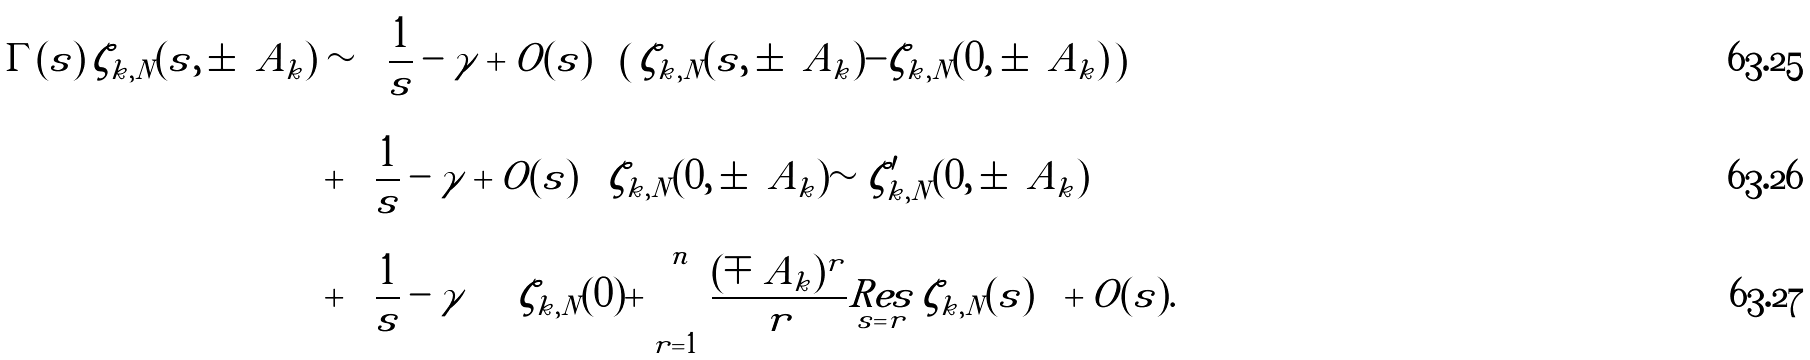Convert formula to latex. <formula><loc_0><loc_0><loc_500><loc_500>\Gamma ( s ) \, \zeta _ { k , N } ( s , \pm \ A _ { k } ) & \sim \left ( \frac { 1 } { s } - \gamma + O ( s ) \right ) \left ( \, \zeta _ { k , N } ( s , \pm \ A _ { k } ) - \zeta _ { k , N } ( 0 , \pm \ A _ { k } ) \, \right ) \\ & + \left ( \frac { 1 } { s } - \gamma + O ( s ) \right ) \zeta _ { k , N } ( 0 , \pm \ A _ { k } ) \sim \zeta ^ { \prime } _ { k , N } ( 0 , \pm \ A _ { k } ) \\ & + \left ( \frac { 1 } { s } - \gamma \right ) \left ( \zeta _ { k , N } ( 0 ) + \sum _ { r = 1 } ^ { n } \frac { ( \mp \ A _ { k } ) ^ { r } } { r } \underset { s = r } { R e s } \, \zeta _ { k , N } ( s ) \right ) + O ( s ) .</formula> 